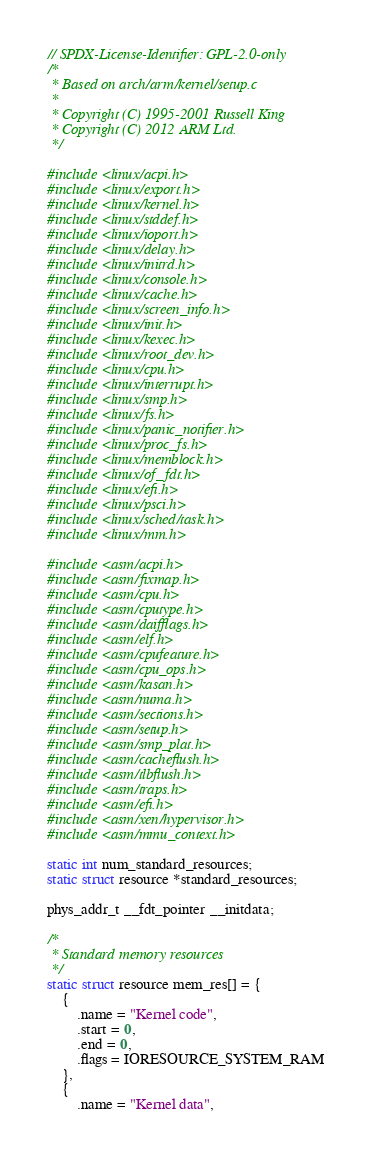Convert code to text. <code><loc_0><loc_0><loc_500><loc_500><_C_>// SPDX-License-Identifier: GPL-2.0-only
/*
 * Based on arch/arm/kernel/setup.c
 *
 * Copyright (C) 1995-2001 Russell King
 * Copyright (C) 2012 ARM Ltd.
 */

#include <linux/acpi.h>
#include <linux/export.h>
#include <linux/kernel.h>
#include <linux/stddef.h>
#include <linux/ioport.h>
#include <linux/delay.h>
#include <linux/initrd.h>
#include <linux/console.h>
#include <linux/cache.h>
#include <linux/screen_info.h>
#include <linux/init.h>
#include <linux/kexec.h>
#include <linux/root_dev.h>
#include <linux/cpu.h>
#include <linux/interrupt.h>
#include <linux/smp.h>
#include <linux/fs.h>
#include <linux/panic_notifier.h>
#include <linux/proc_fs.h>
#include <linux/memblock.h>
#include <linux/of_fdt.h>
#include <linux/efi.h>
#include <linux/psci.h>
#include <linux/sched/task.h>
#include <linux/mm.h>

#include <asm/acpi.h>
#include <asm/fixmap.h>
#include <asm/cpu.h>
#include <asm/cputype.h>
#include <asm/daifflags.h>
#include <asm/elf.h>
#include <asm/cpufeature.h>
#include <asm/cpu_ops.h>
#include <asm/kasan.h>
#include <asm/numa.h>
#include <asm/sections.h>
#include <asm/setup.h>
#include <asm/smp_plat.h>
#include <asm/cacheflush.h>
#include <asm/tlbflush.h>
#include <asm/traps.h>
#include <asm/efi.h>
#include <asm/xen/hypervisor.h>
#include <asm/mmu_context.h>

static int num_standard_resources;
static struct resource *standard_resources;

phys_addr_t __fdt_pointer __initdata;

/*
 * Standard memory resources
 */
static struct resource mem_res[] = {
	{
		.name = "Kernel code",
		.start = 0,
		.end = 0,
		.flags = IORESOURCE_SYSTEM_RAM
	},
	{
		.name = "Kernel data",</code> 